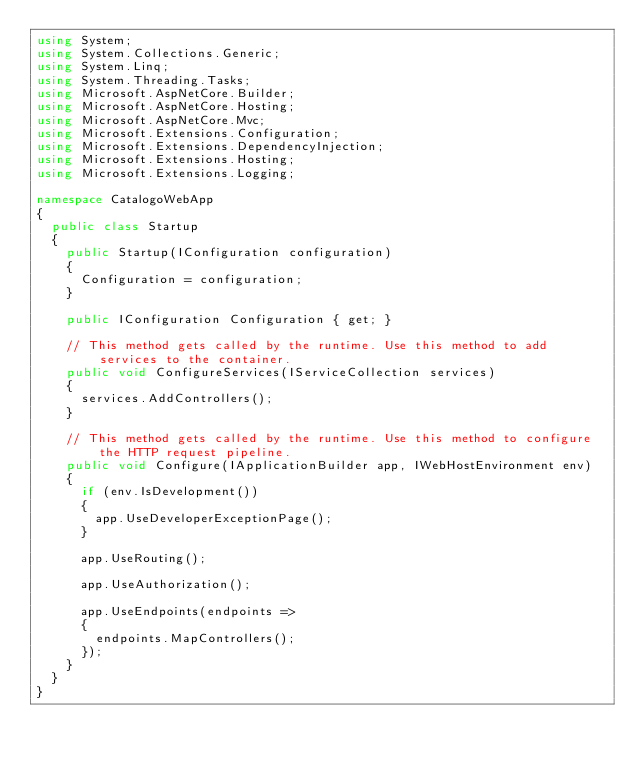Convert code to text. <code><loc_0><loc_0><loc_500><loc_500><_C#_>using System;
using System.Collections.Generic;
using System.Linq;
using System.Threading.Tasks;
using Microsoft.AspNetCore.Builder;
using Microsoft.AspNetCore.Hosting;
using Microsoft.AspNetCore.Mvc;
using Microsoft.Extensions.Configuration;
using Microsoft.Extensions.DependencyInjection;
using Microsoft.Extensions.Hosting;
using Microsoft.Extensions.Logging;

namespace CatalogoWebApp
{
	public class Startup
	{
		public Startup(IConfiguration configuration)
		{
			Configuration = configuration;
		}

		public IConfiguration Configuration { get; }

		// This method gets called by the runtime. Use this method to add services to the container.
		public void ConfigureServices(IServiceCollection services)
		{
			services.AddControllers();
		}

		// This method gets called by the runtime. Use this method to configure the HTTP request pipeline.
		public void Configure(IApplicationBuilder app, IWebHostEnvironment env)
		{
			if (env.IsDevelopment())
			{
				app.UseDeveloperExceptionPage();
			}

			app.UseRouting();

			app.UseAuthorization();

			app.UseEndpoints(endpoints =>
			{
				endpoints.MapControllers();
			});
		}
	}
}
</code> 